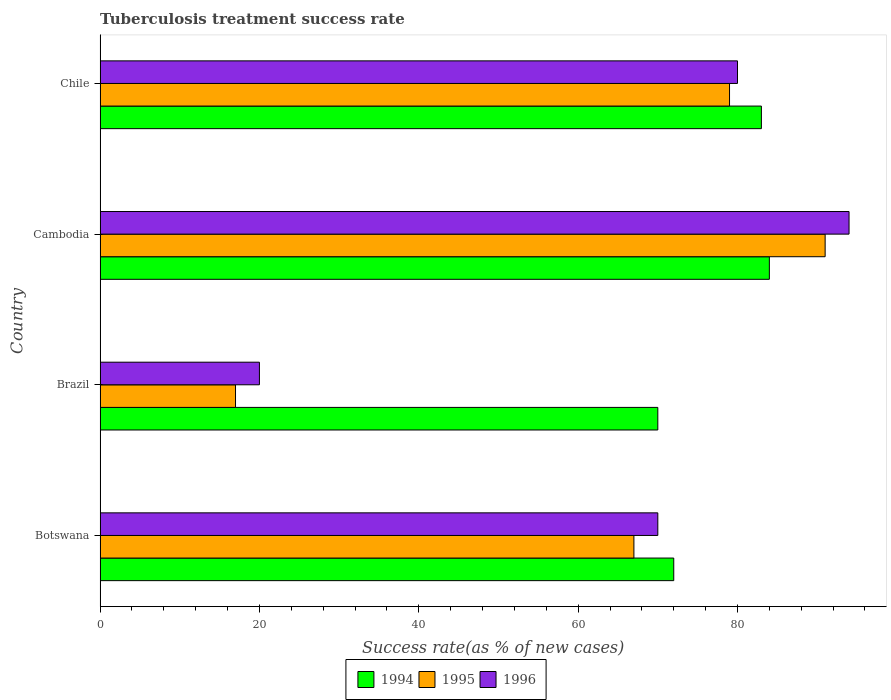Are the number of bars on each tick of the Y-axis equal?
Provide a short and direct response. Yes. How many bars are there on the 1st tick from the top?
Your response must be concise. 3. How many bars are there on the 4th tick from the bottom?
Offer a terse response. 3. What is the label of the 2nd group of bars from the top?
Offer a terse response. Cambodia. Across all countries, what is the maximum tuberculosis treatment success rate in 1994?
Your response must be concise. 84. Across all countries, what is the minimum tuberculosis treatment success rate in 1994?
Make the answer very short. 70. In which country was the tuberculosis treatment success rate in 1996 maximum?
Make the answer very short. Cambodia. What is the total tuberculosis treatment success rate in 1996 in the graph?
Offer a terse response. 264. What is the difference between the tuberculosis treatment success rate in 1996 in Botswana and that in Chile?
Offer a terse response. -10. What is the ratio of the tuberculosis treatment success rate in 1995 in Botswana to that in Brazil?
Provide a short and direct response. 3.94. Is the difference between the tuberculosis treatment success rate in 1995 in Brazil and Chile greater than the difference between the tuberculosis treatment success rate in 1994 in Brazil and Chile?
Offer a terse response. No. What is the difference between the highest and the second highest tuberculosis treatment success rate in 1994?
Your response must be concise. 1. What does the 3rd bar from the top in Brazil represents?
Your answer should be very brief. 1994. How many bars are there?
Provide a short and direct response. 12. Are all the bars in the graph horizontal?
Keep it short and to the point. Yes. How many countries are there in the graph?
Ensure brevity in your answer.  4. Are the values on the major ticks of X-axis written in scientific E-notation?
Provide a short and direct response. No. Does the graph contain any zero values?
Your response must be concise. No. How many legend labels are there?
Make the answer very short. 3. How are the legend labels stacked?
Give a very brief answer. Horizontal. What is the title of the graph?
Ensure brevity in your answer.  Tuberculosis treatment success rate. What is the label or title of the X-axis?
Your answer should be compact. Success rate(as % of new cases). What is the Success rate(as % of new cases) in 1994 in Botswana?
Provide a succinct answer. 72. What is the Success rate(as % of new cases) in 1995 in Botswana?
Ensure brevity in your answer.  67. What is the Success rate(as % of new cases) in 1996 in Botswana?
Offer a very short reply. 70. What is the Success rate(as % of new cases) in 1994 in Brazil?
Offer a very short reply. 70. What is the Success rate(as % of new cases) in 1995 in Cambodia?
Provide a short and direct response. 91. What is the Success rate(as % of new cases) of 1996 in Cambodia?
Make the answer very short. 94. What is the Success rate(as % of new cases) of 1994 in Chile?
Offer a terse response. 83. What is the Success rate(as % of new cases) of 1995 in Chile?
Offer a very short reply. 79. What is the Success rate(as % of new cases) of 1996 in Chile?
Offer a very short reply. 80. Across all countries, what is the maximum Success rate(as % of new cases) of 1995?
Ensure brevity in your answer.  91. Across all countries, what is the maximum Success rate(as % of new cases) of 1996?
Your response must be concise. 94. Across all countries, what is the minimum Success rate(as % of new cases) of 1994?
Your answer should be compact. 70. Across all countries, what is the minimum Success rate(as % of new cases) of 1995?
Provide a succinct answer. 17. Across all countries, what is the minimum Success rate(as % of new cases) in 1996?
Give a very brief answer. 20. What is the total Success rate(as % of new cases) of 1994 in the graph?
Keep it short and to the point. 309. What is the total Success rate(as % of new cases) of 1995 in the graph?
Your response must be concise. 254. What is the total Success rate(as % of new cases) in 1996 in the graph?
Ensure brevity in your answer.  264. What is the difference between the Success rate(as % of new cases) in 1994 in Botswana and that in Brazil?
Your answer should be compact. 2. What is the difference between the Success rate(as % of new cases) in 1995 in Botswana and that in Brazil?
Your answer should be very brief. 50. What is the difference between the Success rate(as % of new cases) of 1994 in Botswana and that in Cambodia?
Your answer should be very brief. -12. What is the difference between the Success rate(as % of new cases) of 1996 in Botswana and that in Cambodia?
Your answer should be compact. -24. What is the difference between the Success rate(as % of new cases) in 1994 in Botswana and that in Chile?
Give a very brief answer. -11. What is the difference between the Success rate(as % of new cases) in 1994 in Brazil and that in Cambodia?
Make the answer very short. -14. What is the difference between the Success rate(as % of new cases) of 1995 in Brazil and that in Cambodia?
Ensure brevity in your answer.  -74. What is the difference between the Success rate(as % of new cases) in 1996 in Brazil and that in Cambodia?
Give a very brief answer. -74. What is the difference between the Success rate(as % of new cases) in 1994 in Brazil and that in Chile?
Your answer should be very brief. -13. What is the difference between the Success rate(as % of new cases) in 1995 in Brazil and that in Chile?
Your response must be concise. -62. What is the difference between the Success rate(as % of new cases) of 1996 in Brazil and that in Chile?
Your answer should be very brief. -60. What is the difference between the Success rate(as % of new cases) in 1994 in Cambodia and that in Chile?
Provide a succinct answer. 1. What is the difference between the Success rate(as % of new cases) in 1994 in Botswana and the Success rate(as % of new cases) in 1995 in Brazil?
Your answer should be very brief. 55. What is the difference between the Success rate(as % of new cases) in 1994 in Botswana and the Success rate(as % of new cases) in 1996 in Cambodia?
Offer a terse response. -22. What is the difference between the Success rate(as % of new cases) in 1994 in Botswana and the Success rate(as % of new cases) in 1995 in Chile?
Provide a succinct answer. -7. What is the difference between the Success rate(as % of new cases) of 1994 in Botswana and the Success rate(as % of new cases) of 1996 in Chile?
Ensure brevity in your answer.  -8. What is the difference between the Success rate(as % of new cases) in 1994 in Brazil and the Success rate(as % of new cases) in 1995 in Cambodia?
Keep it short and to the point. -21. What is the difference between the Success rate(as % of new cases) of 1994 in Brazil and the Success rate(as % of new cases) of 1996 in Cambodia?
Ensure brevity in your answer.  -24. What is the difference between the Success rate(as % of new cases) in 1995 in Brazil and the Success rate(as % of new cases) in 1996 in Cambodia?
Give a very brief answer. -77. What is the difference between the Success rate(as % of new cases) in 1994 in Brazil and the Success rate(as % of new cases) in 1995 in Chile?
Give a very brief answer. -9. What is the difference between the Success rate(as % of new cases) of 1994 in Brazil and the Success rate(as % of new cases) of 1996 in Chile?
Keep it short and to the point. -10. What is the difference between the Success rate(as % of new cases) in 1995 in Brazil and the Success rate(as % of new cases) in 1996 in Chile?
Your response must be concise. -63. What is the difference between the Success rate(as % of new cases) in 1994 in Cambodia and the Success rate(as % of new cases) in 1995 in Chile?
Give a very brief answer. 5. What is the difference between the Success rate(as % of new cases) in 1994 in Cambodia and the Success rate(as % of new cases) in 1996 in Chile?
Provide a short and direct response. 4. What is the difference between the Success rate(as % of new cases) of 1995 in Cambodia and the Success rate(as % of new cases) of 1996 in Chile?
Provide a short and direct response. 11. What is the average Success rate(as % of new cases) in 1994 per country?
Your response must be concise. 77.25. What is the average Success rate(as % of new cases) in 1995 per country?
Provide a succinct answer. 63.5. What is the average Success rate(as % of new cases) of 1996 per country?
Your answer should be compact. 66. What is the difference between the Success rate(as % of new cases) in 1994 and Success rate(as % of new cases) in 1995 in Brazil?
Your response must be concise. 53. What is the difference between the Success rate(as % of new cases) of 1994 and Success rate(as % of new cases) of 1995 in Cambodia?
Keep it short and to the point. -7. What is the difference between the Success rate(as % of new cases) of 1994 and Success rate(as % of new cases) of 1995 in Chile?
Provide a succinct answer. 4. What is the difference between the Success rate(as % of new cases) in 1994 and Success rate(as % of new cases) in 1996 in Chile?
Offer a terse response. 3. What is the difference between the Success rate(as % of new cases) in 1995 and Success rate(as % of new cases) in 1996 in Chile?
Keep it short and to the point. -1. What is the ratio of the Success rate(as % of new cases) of 1994 in Botswana to that in Brazil?
Keep it short and to the point. 1.03. What is the ratio of the Success rate(as % of new cases) in 1995 in Botswana to that in Brazil?
Give a very brief answer. 3.94. What is the ratio of the Success rate(as % of new cases) in 1994 in Botswana to that in Cambodia?
Offer a terse response. 0.86. What is the ratio of the Success rate(as % of new cases) of 1995 in Botswana to that in Cambodia?
Your response must be concise. 0.74. What is the ratio of the Success rate(as % of new cases) of 1996 in Botswana to that in Cambodia?
Make the answer very short. 0.74. What is the ratio of the Success rate(as % of new cases) in 1994 in Botswana to that in Chile?
Your response must be concise. 0.87. What is the ratio of the Success rate(as % of new cases) of 1995 in Botswana to that in Chile?
Provide a succinct answer. 0.85. What is the ratio of the Success rate(as % of new cases) in 1996 in Botswana to that in Chile?
Make the answer very short. 0.88. What is the ratio of the Success rate(as % of new cases) in 1994 in Brazil to that in Cambodia?
Provide a succinct answer. 0.83. What is the ratio of the Success rate(as % of new cases) in 1995 in Brazil to that in Cambodia?
Your response must be concise. 0.19. What is the ratio of the Success rate(as % of new cases) in 1996 in Brazil to that in Cambodia?
Your answer should be compact. 0.21. What is the ratio of the Success rate(as % of new cases) of 1994 in Brazil to that in Chile?
Offer a very short reply. 0.84. What is the ratio of the Success rate(as % of new cases) of 1995 in Brazil to that in Chile?
Your response must be concise. 0.22. What is the ratio of the Success rate(as % of new cases) of 1994 in Cambodia to that in Chile?
Your answer should be very brief. 1.01. What is the ratio of the Success rate(as % of new cases) of 1995 in Cambodia to that in Chile?
Your answer should be very brief. 1.15. What is the ratio of the Success rate(as % of new cases) of 1996 in Cambodia to that in Chile?
Keep it short and to the point. 1.18. What is the difference between the highest and the second highest Success rate(as % of new cases) of 1994?
Make the answer very short. 1. What is the difference between the highest and the second highest Success rate(as % of new cases) of 1995?
Make the answer very short. 12. What is the difference between the highest and the second highest Success rate(as % of new cases) in 1996?
Ensure brevity in your answer.  14. What is the difference between the highest and the lowest Success rate(as % of new cases) of 1994?
Your answer should be very brief. 14. What is the difference between the highest and the lowest Success rate(as % of new cases) in 1996?
Your answer should be very brief. 74. 